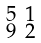<formula> <loc_0><loc_0><loc_500><loc_500>\begin{smallmatrix} 5 & 1 \\ 9 & 2 \end{smallmatrix}</formula> 